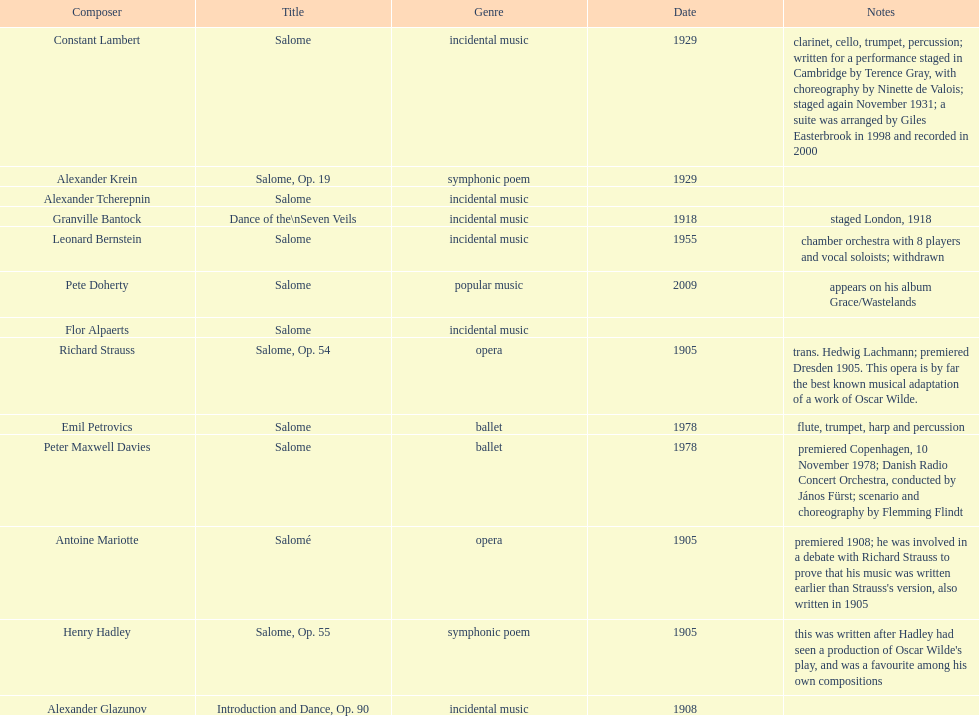What is the count of works named "salome"? 11. 